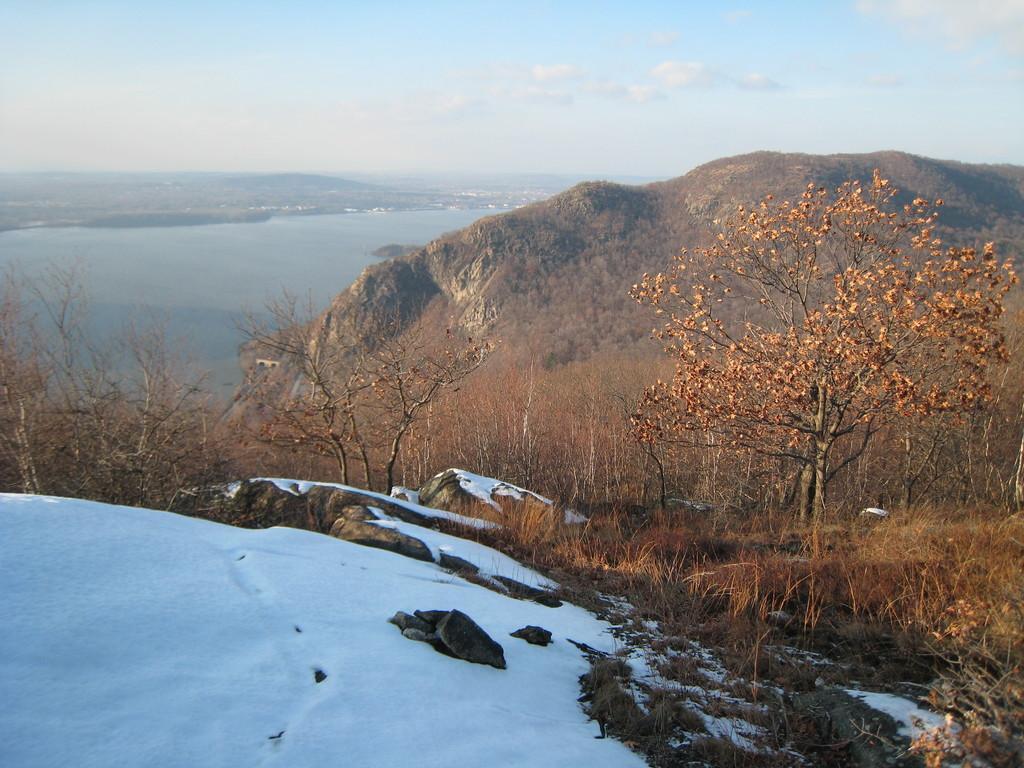Please provide a concise description of this image. In this image there are mountains, trees, one mountain is covered with snow, in the background there is a lake and the sky. 